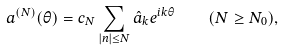Convert formula to latex. <formula><loc_0><loc_0><loc_500><loc_500>a ^ { ( N ) } ( \theta ) = c _ { N } \sum _ { | n | \leq N } \hat { a } _ { k } e ^ { i k \theta } \quad ( N \geq N _ { 0 } ) ,</formula> 